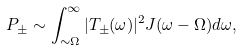<formula> <loc_0><loc_0><loc_500><loc_500>P _ { \pm } \sim \int _ { \sim \Omega } ^ { \infty } | T _ { \pm } ( \omega ) | ^ { 2 } J ( \omega - \Omega ) d \omega ,</formula> 